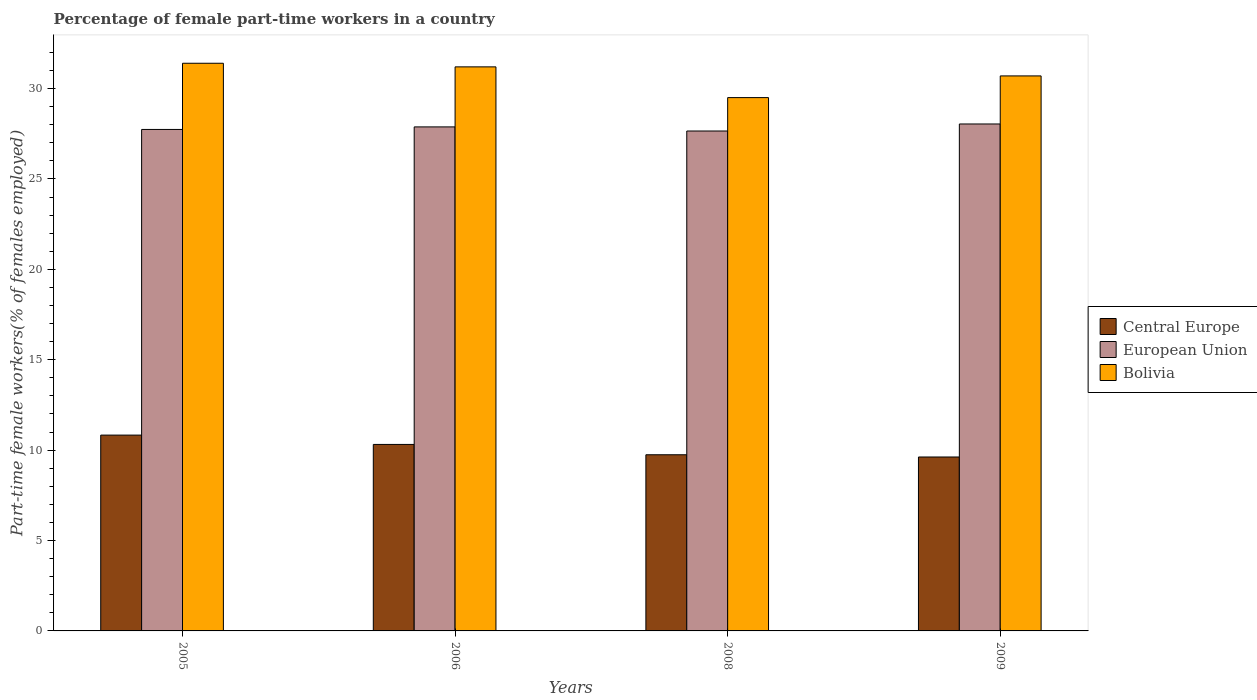How many different coloured bars are there?
Your answer should be very brief. 3. Are the number of bars per tick equal to the number of legend labels?
Ensure brevity in your answer.  Yes. Are the number of bars on each tick of the X-axis equal?
Provide a succinct answer. Yes. How many bars are there on the 2nd tick from the left?
Provide a succinct answer. 3. How many bars are there on the 2nd tick from the right?
Offer a very short reply. 3. What is the percentage of female part-time workers in Central Europe in 2005?
Provide a succinct answer. 10.83. Across all years, what is the maximum percentage of female part-time workers in European Union?
Give a very brief answer. 28.04. Across all years, what is the minimum percentage of female part-time workers in Bolivia?
Provide a short and direct response. 29.5. In which year was the percentage of female part-time workers in Bolivia maximum?
Give a very brief answer. 2005. In which year was the percentage of female part-time workers in Central Europe minimum?
Your answer should be compact. 2009. What is the total percentage of female part-time workers in Bolivia in the graph?
Offer a very short reply. 122.8. What is the difference between the percentage of female part-time workers in European Union in 2006 and that in 2009?
Your response must be concise. -0.16. What is the difference between the percentage of female part-time workers in Bolivia in 2005 and the percentage of female part-time workers in European Union in 2009?
Provide a succinct answer. 3.36. What is the average percentage of female part-time workers in European Union per year?
Keep it short and to the point. 27.83. In the year 2005, what is the difference between the percentage of female part-time workers in Bolivia and percentage of female part-time workers in European Union?
Offer a terse response. 3.66. What is the ratio of the percentage of female part-time workers in Central Europe in 2006 to that in 2008?
Ensure brevity in your answer.  1.06. Is the difference between the percentage of female part-time workers in Bolivia in 2005 and 2009 greater than the difference between the percentage of female part-time workers in European Union in 2005 and 2009?
Keep it short and to the point. Yes. What is the difference between the highest and the second highest percentage of female part-time workers in Bolivia?
Offer a terse response. 0.2. What is the difference between the highest and the lowest percentage of female part-time workers in Central Europe?
Offer a terse response. 1.21. What does the 3rd bar from the left in 2006 represents?
Give a very brief answer. Bolivia. What does the 3rd bar from the right in 2005 represents?
Your answer should be very brief. Central Europe. Is it the case that in every year, the sum of the percentage of female part-time workers in Central Europe and percentage of female part-time workers in Bolivia is greater than the percentage of female part-time workers in European Union?
Make the answer very short. Yes. How many years are there in the graph?
Keep it short and to the point. 4. Where does the legend appear in the graph?
Your answer should be compact. Center right. What is the title of the graph?
Keep it short and to the point. Percentage of female part-time workers in a country. Does "South Africa" appear as one of the legend labels in the graph?
Provide a short and direct response. No. What is the label or title of the X-axis?
Offer a very short reply. Years. What is the label or title of the Y-axis?
Ensure brevity in your answer.  Part-time female workers(% of females employed). What is the Part-time female workers(% of females employed) in Central Europe in 2005?
Your response must be concise. 10.83. What is the Part-time female workers(% of females employed) of European Union in 2005?
Provide a short and direct response. 27.74. What is the Part-time female workers(% of females employed) in Bolivia in 2005?
Keep it short and to the point. 31.4. What is the Part-time female workers(% of females employed) of Central Europe in 2006?
Keep it short and to the point. 10.32. What is the Part-time female workers(% of females employed) in European Union in 2006?
Your answer should be very brief. 27.88. What is the Part-time female workers(% of females employed) of Bolivia in 2006?
Your answer should be compact. 31.2. What is the Part-time female workers(% of females employed) in Central Europe in 2008?
Provide a short and direct response. 9.74. What is the Part-time female workers(% of females employed) in European Union in 2008?
Ensure brevity in your answer.  27.65. What is the Part-time female workers(% of females employed) of Bolivia in 2008?
Make the answer very short. 29.5. What is the Part-time female workers(% of females employed) of Central Europe in 2009?
Your response must be concise. 9.62. What is the Part-time female workers(% of females employed) in European Union in 2009?
Keep it short and to the point. 28.04. What is the Part-time female workers(% of females employed) in Bolivia in 2009?
Your response must be concise. 30.7. Across all years, what is the maximum Part-time female workers(% of females employed) in Central Europe?
Your answer should be very brief. 10.83. Across all years, what is the maximum Part-time female workers(% of females employed) of European Union?
Provide a succinct answer. 28.04. Across all years, what is the maximum Part-time female workers(% of females employed) in Bolivia?
Ensure brevity in your answer.  31.4. Across all years, what is the minimum Part-time female workers(% of females employed) in Central Europe?
Give a very brief answer. 9.62. Across all years, what is the minimum Part-time female workers(% of females employed) of European Union?
Your answer should be compact. 27.65. Across all years, what is the minimum Part-time female workers(% of females employed) in Bolivia?
Provide a succinct answer. 29.5. What is the total Part-time female workers(% of females employed) of Central Europe in the graph?
Your answer should be very brief. 40.51. What is the total Part-time female workers(% of females employed) of European Union in the graph?
Keep it short and to the point. 111.31. What is the total Part-time female workers(% of females employed) in Bolivia in the graph?
Provide a succinct answer. 122.8. What is the difference between the Part-time female workers(% of females employed) of Central Europe in 2005 and that in 2006?
Your answer should be very brief. 0.52. What is the difference between the Part-time female workers(% of females employed) in European Union in 2005 and that in 2006?
Give a very brief answer. -0.14. What is the difference between the Part-time female workers(% of females employed) of Central Europe in 2005 and that in 2008?
Make the answer very short. 1.09. What is the difference between the Part-time female workers(% of females employed) of European Union in 2005 and that in 2008?
Give a very brief answer. 0.09. What is the difference between the Part-time female workers(% of females employed) of Central Europe in 2005 and that in 2009?
Ensure brevity in your answer.  1.21. What is the difference between the Part-time female workers(% of females employed) of European Union in 2005 and that in 2009?
Provide a succinct answer. -0.3. What is the difference between the Part-time female workers(% of females employed) in Central Europe in 2006 and that in 2008?
Your answer should be very brief. 0.57. What is the difference between the Part-time female workers(% of females employed) of European Union in 2006 and that in 2008?
Make the answer very short. 0.23. What is the difference between the Part-time female workers(% of females employed) of Central Europe in 2006 and that in 2009?
Offer a very short reply. 0.69. What is the difference between the Part-time female workers(% of females employed) in European Union in 2006 and that in 2009?
Your response must be concise. -0.16. What is the difference between the Part-time female workers(% of females employed) in Bolivia in 2006 and that in 2009?
Your answer should be very brief. 0.5. What is the difference between the Part-time female workers(% of females employed) in Central Europe in 2008 and that in 2009?
Make the answer very short. 0.12. What is the difference between the Part-time female workers(% of females employed) of European Union in 2008 and that in 2009?
Make the answer very short. -0.39. What is the difference between the Part-time female workers(% of females employed) in Central Europe in 2005 and the Part-time female workers(% of females employed) in European Union in 2006?
Your answer should be very brief. -17.05. What is the difference between the Part-time female workers(% of females employed) of Central Europe in 2005 and the Part-time female workers(% of females employed) of Bolivia in 2006?
Offer a terse response. -20.37. What is the difference between the Part-time female workers(% of females employed) of European Union in 2005 and the Part-time female workers(% of females employed) of Bolivia in 2006?
Make the answer very short. -3.46. What is the difference between the Part-time female workers(% of females employed) of Central Europe in 2005 and the Part-time female workers(% of females employed) of European Union in 2008?
Offer a very short reply. -16.82. What is the difference between the Part-time female workers(% of females employed) in Central Europe in 2005 and the Part-time female workers(% of females employed) in Bolivia in 2008?
Provide a short and direct response. -18.67. What is the difference between the Part-time female workers(% of females employed) in European Union in 2005 and the Part-time female workers(% of females employed) in Bolivia in 2008?
Offer a terse response. -1.76. What is the difference between the Part-time female workers(% of females employed) of Central Europe in 2005 and the Part-time female workers(% of females employed) of European Union in 2009?
Offer a very short reply. -17.21. What is the difference between the Part-time female workers(% of females employed) in Central Europe in 2005 and the Part-time female workers(% of females employed) in Bolivia in 2009?
Your answer should be compact. -19.87. What is the difference between the Part-time female workers(% of females employed) in European Union in 2005 and the Part-time female workers(% of females employed) in Bolivia in 2009?
Your response must be concise. -2.96. What is the difference between the Part-time female workers(% of females employed) in Central Europe in 2006 and the Part-time female workers(% of females employed) in European Union in 2008?
Your answer should be very brief. -17.34. What is the difference between the Part-time female workers(% of females employed) in Central Europe in 2006 and the Part-time female workers(% of females employed) in Bolivia in 2008?
Keep it short and to the point. -19.18. What is the difference between the Part-time female workers(% of females employed) of European Union in 2006 and the Part-time female workers(% of females employed) of Bolivia in 2008?
Give a very brief answer. -1.62. What is the difference between the Part-time female workers(% of females employed) in Central Europe in 2006 and the Part-time female workers(% of females employed) in European Union in 2009?
Make the answer very short. -17.73. What is the difference between the Part-time female workers(% of females employed) in Central Europe in 2006 and the Part-time female workers(% of females employed) in Bolivia in 2009?
Provide a succinct answer. -20.38. What is the difference between the Part-time female workers(% of females employed) of European Union in 2006 and the Part-time female workers(% of females employed) of Bolivia in 2009?
Ensure brevity in your answer.  -2.82. What is the difference between the Part-time female workers(% of females employed) of Central Europe in 2008 and the Part-time female workers(% of females employed) of European Union in 2009?
Offer a very short reply. -18.3. What is the difference between the Part-time female workers(% of females employed) of Central Europe in 2008 and the Part-time female workers(% of females employed) of Bolivia in 2009?
Offer a terse response. -20.96. What is the difference between the Part-time female workers(% of females employed) in European Union in 2008 and the Part-time female workers(% of females employed) in Bolivia in 2009?
Give a very brief answer. -3.05. What is the average Part-time female workers(% of females employed) in Central Europe per year?
Your answer should be compact. 10.13. What is the average Part-time female workers(% of females employed) in European Union per year?
Your answer should be very brief. 27.83. What is the average Part-time female workers(% of females employed) of Bolivia per year?
Keep it short and to the point. 30.7. In the year 2005, what is the difference between the Part-time female workers(% of females employed) of Central Europe and Part-time female workers(% of females employed) of European Union?
Offer a very short reply. -16.91. In the year 2005, what is the difference between the Part-time female workers(% of females employed) of Central Europe and Part-time female workers(% of females employed) of Bolivia?
Provide a succinct answer. -20.57. In the year 2005, what is the difference between the Part-time female workers(% of females employed) in European Union and Part-time female workers(% of females employed) in Bolivia?
Your answer should be very brief. -3.66. In the year 2006, what is the difference between the Part-time female workers(% of females employed) of Central Europe and Part-time female workers(% of females employed) of European Union?
Offer a very short reply. -17.56. In the year 2006, what is the difference between the Part-time female workers(% of females employed) of Central Europe and Part-time female workers(% of females employed) of Bolivia?
Provide a succinct answer. -20.88. In the year 2006, what is the difference between the Part-time female workers(% of females employed) in European Union and Part-time female workers(% of females employed) in Bolivia?
Offer a terse response. -3.32. In the year 2008, what is the difference between the Part-time female workers(% of females employed) of Central Europe and Part-time female workers(% of females employed) of European Union?
Keep it short and to the point. -17.91. In the year 2008, what is the difference between the Part-time female workers(% of females employed) in Central Europe and Part-time female workers(% of females employed) in Bolivia?
Offer a terse response. -19.76. In the year 2008, what is the difference between the Part-time female workers(% of females employed) in European Union and Part-time female workers(% of females employed) in Bolivia?
Give a very brief answer. -1.85. In the year 2009, what is the difference between the Part-time female workers(% of females employed) in Central Europe and Part-time female workers(% of females employed) in European Union?
Ensure brevity in your answer.  -18.42. In the year 2009, what is the difference between the Part-time female workers(% of females employed) in Central Europe and Part-time female workers(% of females employed) in Bolivia?
Keep it short and to the point. -21.08. In the year 2009, what is the difference between the Part-time female workers(% of females employed) in European Union and Part-time female workers(% of females employed) in Bolivia?
Provide a short and direct response. -2.66. What is the ratio of the Part-time female workers(% of females employed) in Bolivia in 2005 to that in 2006?
Offer a very short reply. 1.01. What is the ratio of the Part-time female workers(% of females employed) in Central Europe in 2005 to that in 2008?
Ensure brevity in your answer.  1.11. What is the ratio of the Part-time female workers(% of females employed) in European Union in 2005 to that in 2008?
Give a very brief answer. 1. What is the ratio of the Part-time female workers(% of females employed) in Bolivia in 2005 to that in 2008?
Offer a terse response. 1.06. What is the ratio of the Part-time female workers(% of females employed) in Central Europe in 2005 to that in 2009?
Offer a very short reply. 1.13. What is the ratio of the Part-time female workers(% of females employed) in Bolivia in 2005 to that in 2009?
Your answer should be compact. 1.02. What is the ratio of the Part-time female workers(% of females employed) of Central Europe in 2006 to that in 2008?
Your answer should be very brief. 1.06. What is the ratio of the Part-time female workers(% of females employed) in European Union in 2006 to that in 2008?
Provide a short and direct response. 1.01. What is the ratio of the Part-time female workers(% of females employed) of Bolivia in 2006 to that in 2008?
Ensure brevity in your answer.  1.06. What is the ratio of the Part-time female workers(% of females employed) of Central Europe in 2006 to that in 2009?
Make the answer very short. 1.07. What is the ratio of the Part-time female workers(% of females employed) in Bolivia in 2006 to that in 2009?
Ensure brevity in your answer.  1.02. What is the ratio of the Part-time female workers(% of females employed) of Central Europe in 2008 to that in 2009?
Your response must be concise. 1.01. What is the ratio of the Part-time female workers(% of females employed) in European Union in 2008 to that in 2009?
Ensure brevity in your answer.  0.99. What is the ratio of the Part-time female workers(% of females employed) of Bolivia in 2008 to that in 2009?
Offer a very short reply. 0.96. What is the difference between the highest and the second highest Part-time female workers(% of females employed) of Central Europe?
Ensure brevity in your answer.  0.52. What is the difference between the highest and the second highest Part-time female workers(% of females employed) in European Union?
Keep it short and to the point. 0.16. What is the difference between the highest and the lowest Part-time female workers(% of females employed) of Central Europe?
Provide a short and direct response. 1.21. What is the difference between the highest and the lowest Part-time female workers(% of females employed) of European Union?
Keep it short and to the point. 0.39. 